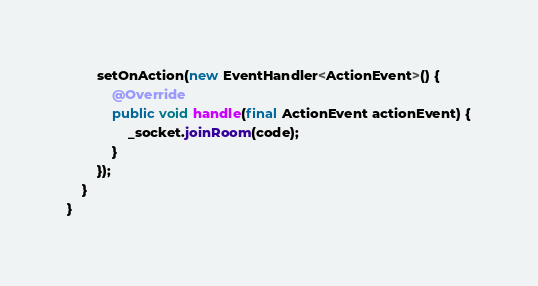<code> <loc_0><loc_0><loc_500><loc_500><_Java_>        setOnAction(new EventHandler<ActionEvent>() {
            @Override
            public void handle(final ActionEvent actionEvent) {
                _socket.joinRoom(code);
            }
        });
    }
}
</code> 